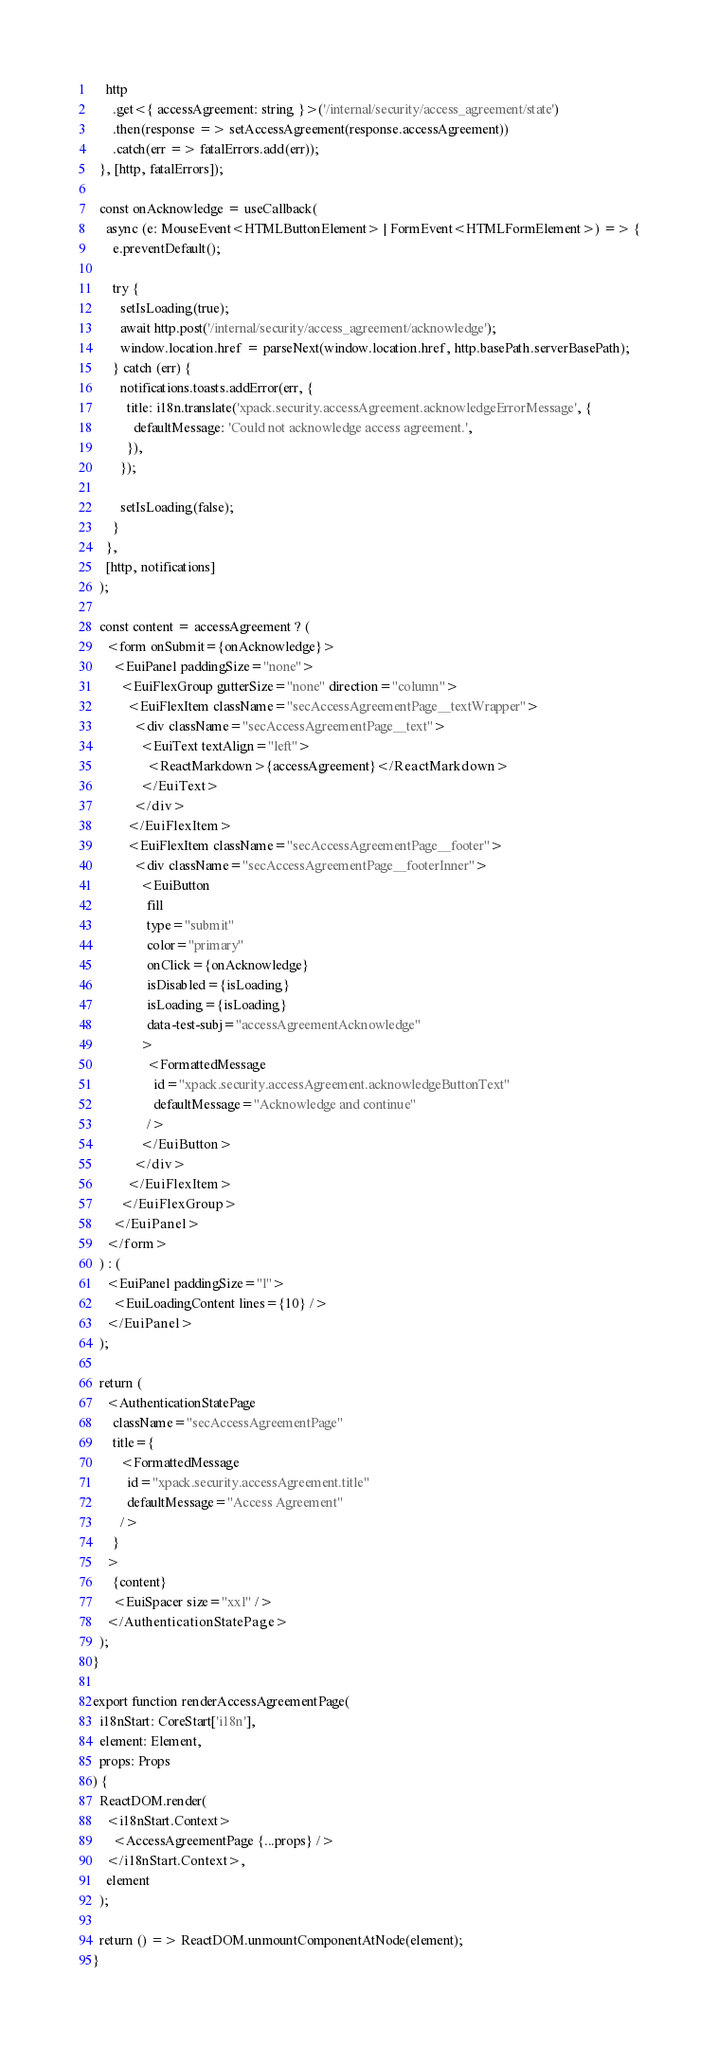<code> <loc_0><loc_0><loc_500><loc_500><_TypeScript_>    http
      .get<{ accessAgreement: string }>('/internal/security/access_agreement/state')
      .then(response => setAccessAgreement(response.accessAgreement))
      .catch(err => fatalErrors.add(err));
  }, [http, fatalErrors]);

  const onAcknowledge = useCallback(
    async (e: MouseEvent<HTMLButtonElement> | FormEvent<HTMLFormElement>) => {
      e.preventDefault();

      try {
        setIsLoading(true);
        await http.post('/internal/security/access_agreement/acknowledge');
        window.location.href = parseNext(window.location.href, http.basePath.serverBasePath);
      } catch (err) {
        notifications.toasts.addError(err, {
          title: i18n.translate('xpack.security.accessAgreement.acknowledgeErrorMessage', {
            defaultMessage: 'Could not acknowledge access agreement.',
          }),
        });

        setIsLoading(false);
      }
    },
    [http, notifications]
  );

  const content = accessAgreement ? (
    <form onSubmit={onAcknowledge}>
      <EuiPanel paddingSize="none">
        <EuiFlexGroup gutterSize="none" direction="column">
          <EuiFlexItem className="secAccessAgreementPage__textWrapper">
            <div className="secAccessAgreementPage__text">
              <EuiText textAlign="left">
                <ReactMarkdown>{accessAgreement}</ReactMarkdown>
              </EuiText>
            </div>
          </EuiFlexItem>
          <EuiFlexItem className="secAccessAgreementPage__footer">
            <div className="secAccessAgreementPage__footerInner">
              <EuiButton
                fill
                type="submit"
                color="primary"
                onClick={onAcknowledge}
                isDisabled={isLoading}
                isLoading={isLoading}
                data-test-subj="accessAgreementAcknowledge"
              >
                <FormattedMessage
                  id="xpack.security.accessAgreement.acknowledgeButtonText"
                  defaultMessage="Acknowledge and continue"
                />
              </EuiButton>
            </div>
          </EuiFlexItem>
        </EuiFlexGroup>
      </EuiPanel>
    </form>
  ) : (
    <EuiPanel paddingSize="l">
      <EuiLoadingContent lines={10} />
    </EuiPanel>
  );

  return (
    <AuthenticationStatePage
      className="secAccessAgreementPage"
      title={
        <FormattedMessage
          id="xpack.security.accessAgreement.title"
          defaultMessage="Access Agreement"
        />
      }
    >
      {content}
      <EuiSpacer size="xxl" />
    </AuthenticationStatePage>
  );
}

export function renderAccessAgreementPage(
  i18nStart: CoreStart['i18n'],
  element: Element,
  props: Props
) {
  ReactDOM.render(
    <i18nStart.Context>
      <AccessAgreementPage {...props} />
    </i18nStart.Context>,
    element
  );

  return () => ReactDOM.unmountComponentAtNode(element);
}
</code> 